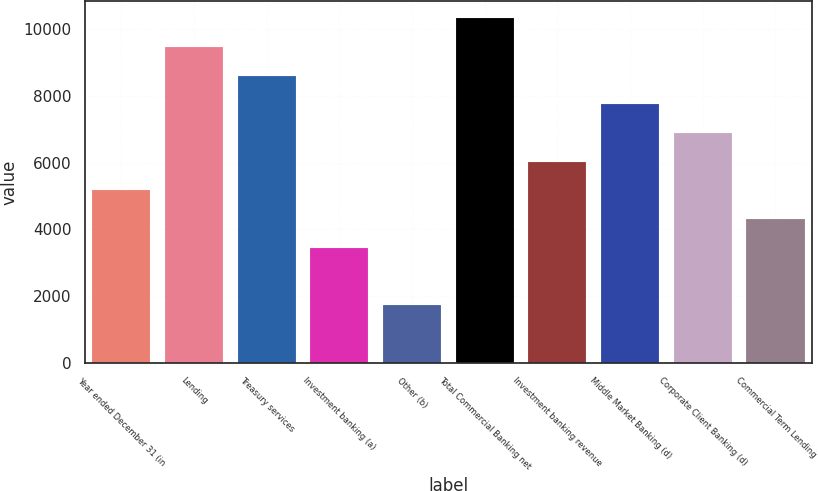Convert chart. <chart><loc_0><loc_0><loc_500><loc_500><bar_chart><fcel>Year ended December 31 (in<fcel>Lending<fcel>Treasury services<fcel>Investment banking (a)<fcel>Other (b)<fcel>Total Commercial Banking net<fcel>Investment banking revenue<fcel>Middle Market Banking (d)<fcel>Corporate Client Banking (d)<fcel>Commercial Term Lending<nl><fcel>5169.8<fcel>9463.8<fcel>8605<fcel>3452.2<fcel>1734.6<fcel>10322.6<fcel>6028.6<fcel>7746.2<fcel>6887.4<fcel>4311<nl></chart> 